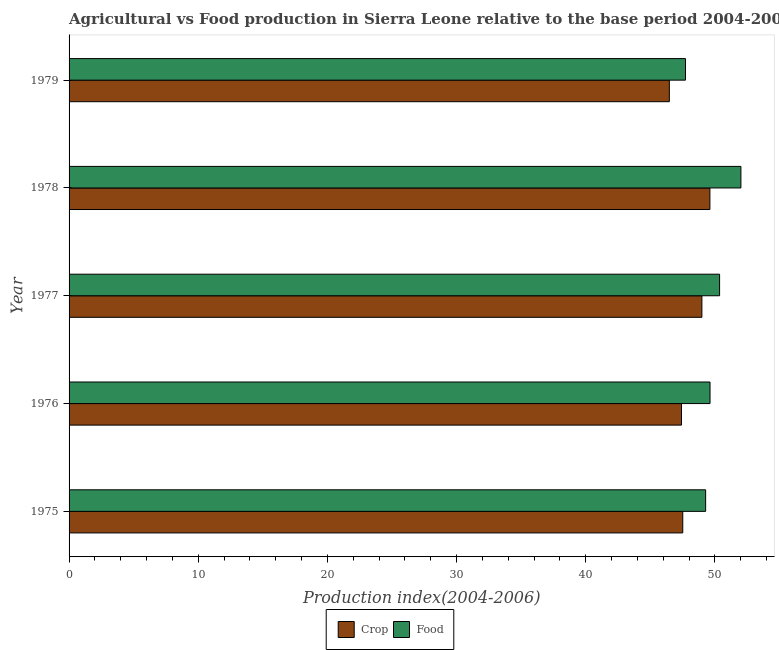How many groups of bars are there?
Your answer should be very brief. 5. Are the number of bars per tick equal to the number of legend labels?
Your answer should be very brief. Yes. How many bars are there on the 2nd tick from the top?
Keep it short and to the point. 2. How many bars are there on the 4th tick from the bottom?
Make the answer very short. 2. What is the crop production index in 1978?
Keep it short and to the point. 49.61. Across all years, what is the maximum crop production index?
Offer a terse response. 49.61. Across all years, what is the minimum crop production index?
Make the answer very short. 46.47. In which year was the crop production index maximum?
Your response must be concise. 1978. In which year was the food production index minimum?
Provide a short and direct response. 1979. What is the total food production index in the graph?
Your response must be concise. 248.99. What is the difference between the crop production index in 1975 and the food production index in 1977?
Provide a short and direct response. -2.85. What is the average food production index per year?
Keep it short and to the point. 49.8. In the year 1977, what is the difference between the crop production index and food production index?
Offer a very short reply. -1.37. What is the ratio of the crop production index in 1977 to that in 1979?
Provide a succinct answer. 1.05. Is the food production index in 1975 less than that in 1977?
Provide a short and direct response. Yes. What is the difference between the highest and the second highest food production index?
Give a very brief answer. 1.65. What is the difference between the highest and the lowest crop production index?
Offer a very short reply. 3.14. In how many years, is the food production index greater than the average food production index taken over all years?
Offer a very short reply. 2. What does the 2nd bar from the top in 1975 represents?
Offer a very short reply. Crop. What does the 2nd bar from the bottom in 1978 represents?
Provide a succinct answer. Food. Are all the bars in the graph horizontal?
Provide a short and direct response. Yes. Are the values on the major ticks of X-axis written in scientific E-notation?
Give a very brief answer. No. Does the graph contain any zero values?
Keep it short and to the point. No. Does the graph contain grids?
Offer a very short reply. No. Where does the legend appear in the graph?
Ensure brevity in your answer.  Bottom center. How are the legend labels stacked?
Make the answer very short. Horizontal. What is the title of the graph?
Give a very brief answer. Agricultural vs Food production in Sierra Leone relative to the base period 2004-2006. What is the label or title of the X-axis?
Provide a short and direct response. Production index(2004-2006). What is the label or title of the Y-axis?
Give a very brief answer. Year. What is the Production index(2004-2006) of Crop in 1975?
Your answer should be compact. 47.51. What is the Production index(2004-2006) of Food in 1975?
Offer a very short reply. 49.28. What is the Production index(2004-2006) in Crop in 1976?
Offer a terse response. 47.41. What is the Production index(2004-2006) in Food in 1976?
Your answer should be very brief. 49.62. What is the Production index(2004-2006) in Crop in 1977?
Make the answer very short. 48.99. What is the Production index(2004-2006) of Food in 1977?
Your response must be concise. 50.36. What is the Production index(2004-2006) in Crop in 1978?
Offer a terse response. 49.61. What is the Production index(2004-2006) in Food in 1978?
Offer a very short reply. 52.01. What is the Production index(2004-2006) in Crop in 1979?
Your answer should be compact. 46.47. What is the Production index(2004-2006) in Food in 1979?
Your answer should be very brief. 47.72. Across all years, what is the maximum Production index(2004-2006) in Crop?
Provide a succinct answer. 49.61. Across all years, what is the maximum Production index(2004-2006) of Food?
Keep it short and to the point. 52.01. Across all years, what is the minimum Production index(2004-2006) of Crop?
Provide a succinct answer. 46.47. Across all years, what is the minimum Production index(2004-2006) in Food?
Ensure brevity in your answer.  47.72. What is the total Production index(2004-2006) of Crop in the graph?
Offer a very short reply. 239.99. What is the total Production index(2004-2006) of Food in the graph?
Keep it short and to the point. 248.99. What is the difference between the Production index(2004-2006) in Crop in 1975 and that in 1976?
Provide a succinct answer. 0.1. What is the difference between the Production index(2004-2006) in Food in 1975 and that in 1976?
Provide a succinct answer. -0.34. What is the difference between the Production index(2004-2006) of Crop in 1975 and that in 1977?
Make the answer very short. -1.48. What is the difference between the Production index(2004-2006) in Food in 1975 and that in 1977?
Your answer should be compact. -1.08. What is the difference between the Production index(2004-2006) of Crop in 1975 and that in 1978?
Offer a terse response. -2.1. What is the difference between the Production index(2004-2006) of Food in 1975 and that in 1978?
Give a very brief answer. -2.73. What is the difference between the Production index(2004-2006) of Food in 1975 and that in 1979?
Your answer should be compact. 1.56. What is the difference between the Production index(2004-2006) in Crop in 1976 and that in 1977?
Provide a short and direct response. -1.58. What is the difference between the Production index(2004-2006) in Food in 1976 and that in 1977?
Your answer should be very brief. -0.74. What is the difference between the Production index(2004-2006) in Food in 1976 and that in 1978?
Keep it short and to the point. -2.39. What is the difference between the Production index(2004-2006) of Crop in 1977 and that in 1978?
Your answer should be compact. -0.62. What is the difference between the Production index(2004-2006) of Food in 1977 and that in 1978?
Your answer should be very brief. -1.65. What is the difference between the Production index(2004-2006) in Crop in 1977 and that in 1979?
Your answer should be compact. 2.52. What is the difference between the Production index(2004-2006) in Food in 1977 and that in 1979?
Make the answer very short. 2.64. What is the difference between the Production index(2004-2006) of Crop in 1978 and that in 1979?
Your response must be concise. 3.14. What is the difference between the Production index(2004-2006) of Food in 1978 and that in 1979?
Keep it short and to the point. 4.29. What is the difference between the Production index(2004-2006) in Crop in 1975 and the Production index(2004-2006) in Food in 1976?
Provide a succinct answer. -2.11. What is the difference between the Production index(2004-2006) in Crop in 1975 and the Production index(2004-2006) in Food in 1977?
Provide a succinct answer. -2.85. What is the difference between the Production index(2004-2006) in Crop in 1975 and the Production index(2004-2006) in Food in 1979?
Give a very brief answer. -0.21. What is the difference between the Production index(2004-2006) in Crop in 1976 and the Production index(2004-2006) in Food in 1977?
Offer a terse response. -2.95. What is the difference between the Production index(2004-2006) of Crop in 1976 and the Production index(2004-2006) of Food in 1978?
Keep it short and to the point. -4.6. What is the difference between the Production index(2004-2006) of Crop in 1976 and the Production index(2004-2006) of Food in 1979?
Your answer should be very brief. -0.31. What is the difference between the Production index(2004-2006) of Crop in 1977 and the Production index(2004-2006) of Food in 1978?
Offer a terse response. -3.02. What is the difference between the Production index(2004-2006) of Crop in 1977 and the Production index(2004-2006) of Food in 1979?
Provide a short and direct response. 1.27. What is the difference between the Production index(2004-2006) in Crop in 1978 and the Production index(2004-2006) in Food in 1979?
Provide a short and direct response. 1.89. What is the average Production index(2004-2006) in Crop per year?
Provide a succinct answer. 48. What is the average Production index(2004-2006) in Food per year?
Provide a short and direct response. 49.8. In the year 1975, what is the difference between the Production index(2004-2006) of Crop and Production index(2004-2006) of Food?
Keep it short and to the point. -1.77. In the year 1976, what is the difference between the Production index(2004-2006) of Crop and Production index(2004-2006) of Food?
Make the answer very short. -2.21. In the year 1977, what is the difference between the Production index(2004-2006) of Crop and Production index(2004-2006) of Food?
Make the answer very short. -1.37. In the year 1978, what is the difference between the Production index(2004-2006) in Crop and Production index(2004-2006) in Food?
Your answer should be compact. -2.4. In the year 1979, what is the difference between the Production index(2004-2006) in Crop and Production index(2004-2006) in Food?
Offer a very short reply. -1.25. What is the ratio of the Production index(2004-2006) of Crop in 1975 to that in 1976?
Offer a terse response. 1. What is the ratio of the Production index(2004-2006) of Food in 1975 to that in 1976?
Give a very brief answer. 0.99. What is the ratio of the Production index(2004-2006) of Crop in 1975 to that in 1977?
Provide a short and direct response. 0.97. What is the ratio of the Production index(2004-2006) in Food in 1975 to that in 1977?
Offer a very short reply. 0.98. What is the ratio of the Production index(2004-2006) in Crop in 1975 to that in 1978?
Make the answer very short. 0.96. What is the ratio of the Production index(2004-2006) in Food in 1975 to that in 1978?
Ensure brevity in your answer.  0.95. What is the ratio of the Production index(2004-2006) in Crop in 1975 to that in 1979?
Provide a short and direct response. 1.02. What is the ratio of the Production index(2004-2006) of Food in 1975 to that in 1979?
Offer a very short reply. 1.03. What is the ratio of the Production index(2004-2006) in Crop in 1976 to that in 1977?
Ensure brevity in your answer.  0.97. What is the ratio of the Production index(2004-2006) of Crop in 1976 to that in 1978?
Offer a terse response. 0.96. What is the ratio of the Production index(2004-2006) of Food in 1976 to that in 1978?
Ensure brevity in your answer.  0.95. What is the ratio of the Production index(2004-2006) in Crop in 1976 to that in 1979?
Offer a terse response. 1.02. What is the ratio of the Production index(2004-2006) in Food in 1976 to that in 1979?
Offer a very short reply. 1.04. What is the ratio of the Production index(2004-2006) in Crop in 1977 to that in 1978?
Provide a succinct answer. 0.99. What is the ratio of the Production index(2004-2006) of Food in 1977 to that in 1978?
Your answer should be compact. 0.97. What is the ratio of the Production index(2004-2006) in Crop in 1977 to that in 1979?
Your answer should be compact. 1.05. What is the ratio of the Production index(2004-2006) in Food in 1977 to that in 1979?
Your answer should be compact. 1.06. What is the ratio of the Production index(2004-2006) of Crop in 1978 to that in 1979?
Provide a short and direct response. 1.07. What is the ratio of the Production index(2004-2006) of Food in 1978 to that in 1979?
Keep it short and to the point. 1.09. What is the difference between the highest and the second highest Production index(2004-2006) of Crop?
Your response must be concise. 0.62. What is the difference between the highest and the second highest Production index(2004-2006) of Food?
Offer a terse response. 1.65. What is the difference between the highest and the lowest Production index(2004-2006) in Crop?
Your response must be concise. 3.14. What is the difference between the highest and the lowest Production index(2004-2006) in Food?
Ensure brevity in your answer.  4.29. 